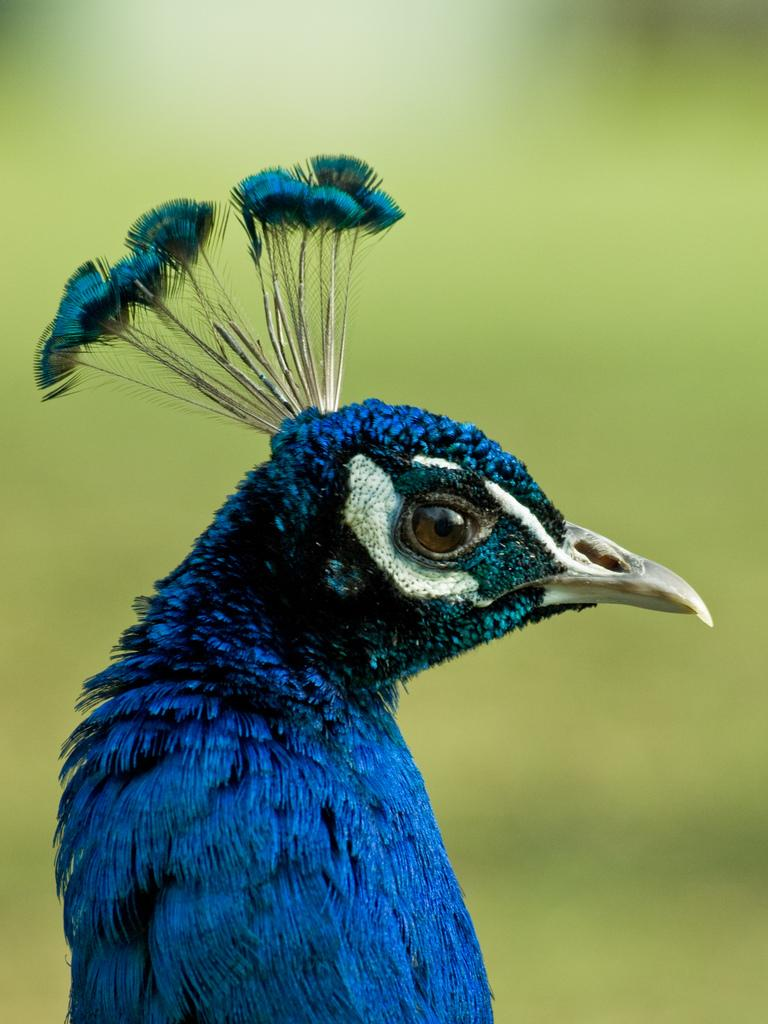What animal is the main subject of the image? There is a peacock in the image. Can you describe the background of the image? The background of the image is blurry. What type of religious symbol can be seen in the image? There is no religious symbol present in the image; it features a peacock. Can you tell me how many dinosaurs are visible in the image? There are no dinosaurs present in the image; it features a peacock. 